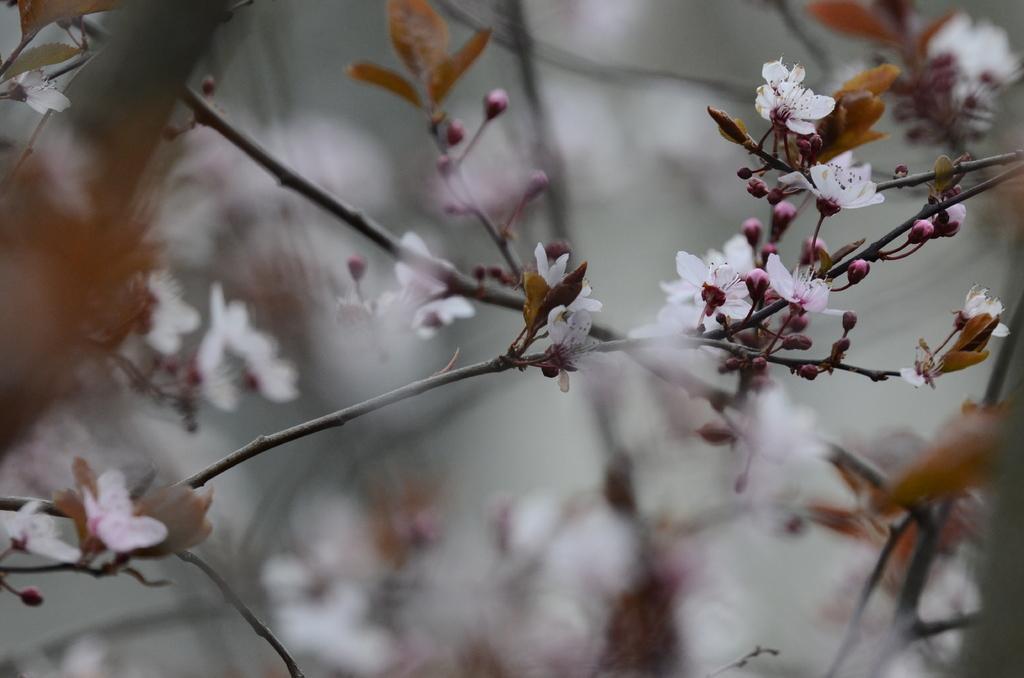Could you give a brief overview of what you see in this image? In this image may be there are stem of trees, on which there are some, flowers, leaves, buds visible. 